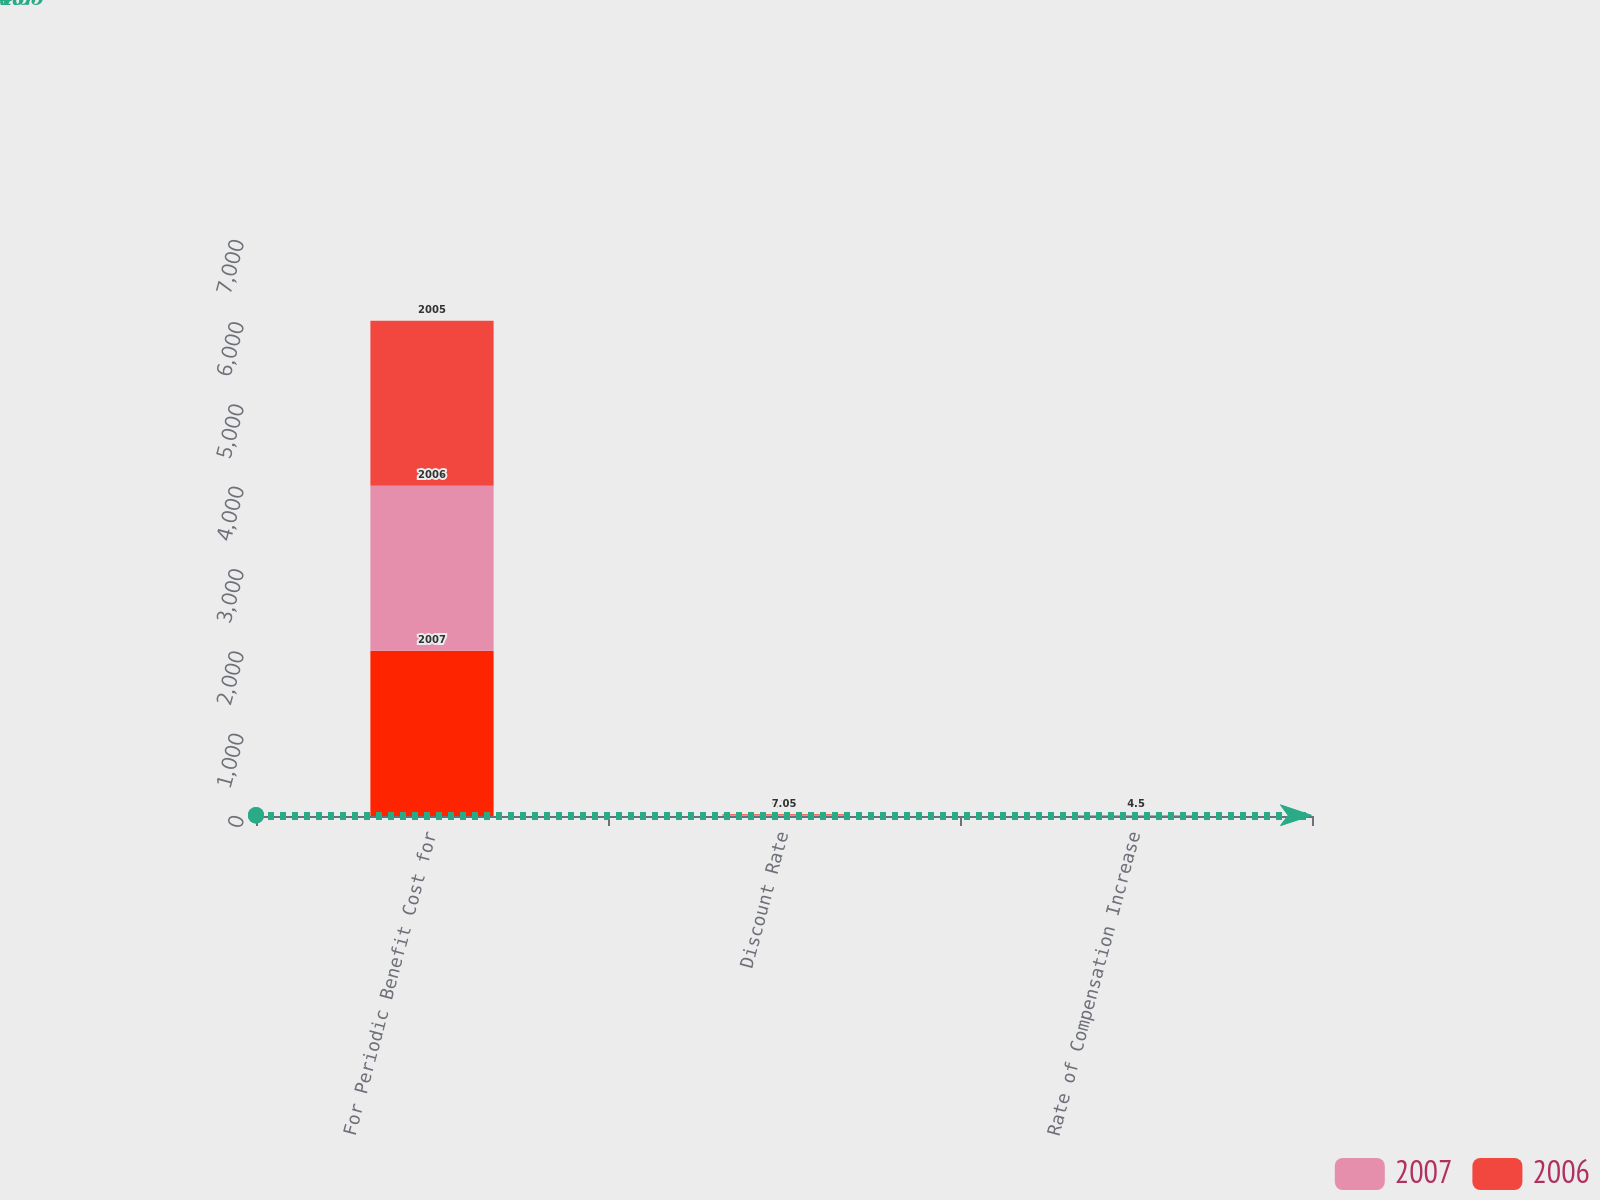<chart> <loc_0><loc_0><loc_500><loc_500><stacked_bar_chart><ecel><fcel>For Periodic Benefit Cost for<fcel>Discount Rate<fcel>Rate of Compensation Increase<nl><fcel>nan<fcel>2007<fcel>6.22<fcel>4.5<nl><fcel>2007<fcel>2006<fcel>7<fcel>4.5<nl><fcel>2006<fcel>2005<fcel>7.05<fcel>4.5<nl></chart> 